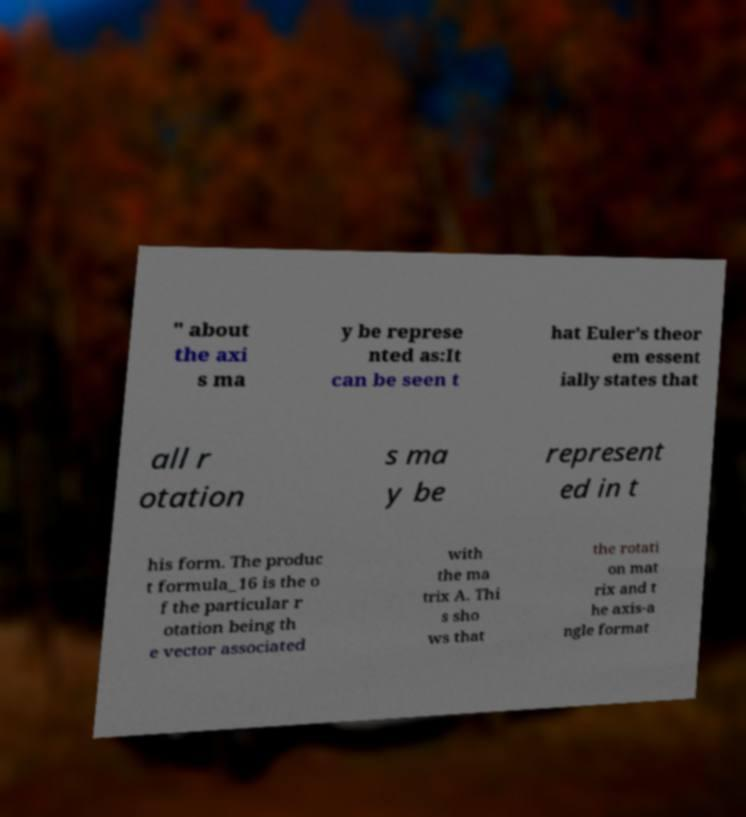There's text embedded in this image that I need extracted. Can you transcribe it verbatim? " about the axi s ma y be represe nted as:It can be seen t hat Euler's theor em essent ially states that all r otation s ma y be represent ed in t his form. The produc t formula_16 is the o f the particular r otation being th e vector associated with the ma trix A. Thi s sho ws that the rotati on mat rix and t he axis-a ngle format 